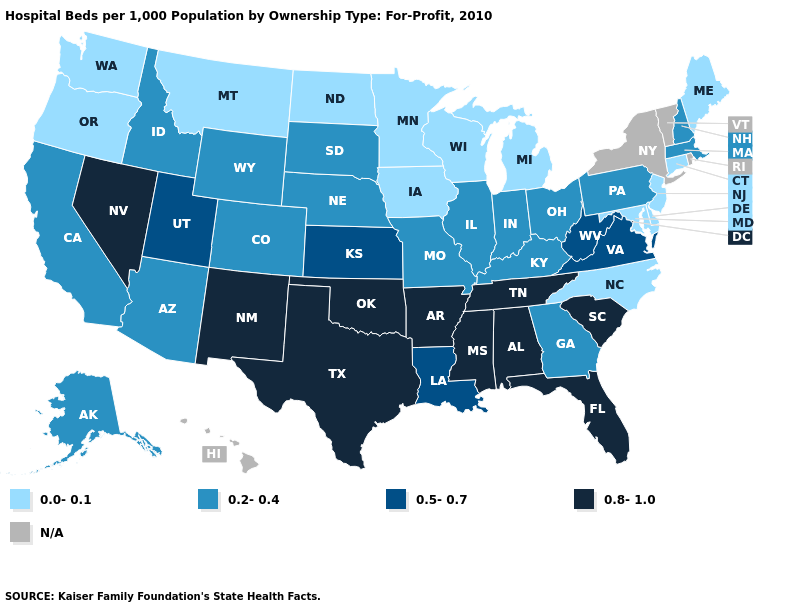Name the states that have a value in the range 0.2-0.4?
Concise answer only. Alaska, Arizona, California, Colorado, Georgia, Idaho, Illinois, Indiana, Kentucky, Massachusetts, Missouri, Nebraska, New Hampshire, Ohio, Pennsylvania, South Dakota, Wyoming. What is the value of Florida?
Short answer required. 0.8-1.0. Among the states that border Minnesota , which have the highest value?
Quick response, please. South Dakota. What is the lowest value in the MidWest?
Answer briefly. 0.0-0.1. Name the states that have a value in the range 0.0-0.1?
Keep it brief. Connecticut, Delaware, Iowa, Maine, Maryland, Michigan, Minnesota, Montana, New Jersey, North Carolina, North Dakota, Oregon, Washington, Wisconsin. What is the lowest value in the Northeast?
Give a very brief answer. 0.0-0.1. Name the states that have a value in the range 0.8-1.0?
Answer briefly. Alabama, Arkansas, Florida, Mississippi, Nevada, New Mexico, Oklahoma, South Carolina, Tennessee, Texas. Among the states that border Maine , which have the highest value?
Give a very brief answer. New Hampshire. What is the value of Washington?
Be succinct. 0.0-0.1. Name the states that have a value in the range 0.5-0.7?
Be succinct. Kansas, Louisiana, Utah, Virginia, West Virginia. What is the value of New Hampshire?
Quick response, please. 0.2-0.4. What is the value of Montana?
Short answer required. 0.0-0.1. Is the legend a continuous bar?
Concise answer only. No. 